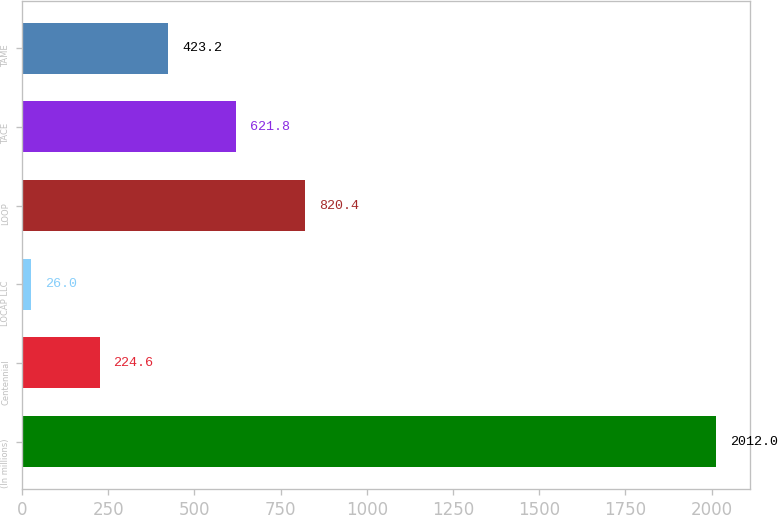Convert chart to OTSL. <chart><loc_0><loc_0><loc_500><loc_500><bar_chart><fcel>(In millions)<fcel>Centennial<fcel>LOCAP LLC<fcel>LOOP<fcel>TACE<fcel>TAME<nl><fcel>2012<fcel>224.6<fcel>26<fcel>820.4<fcel>621.8<fcel>423.2<nl></chart> 